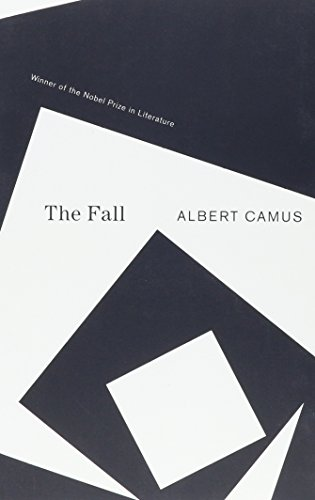Is this book related to Science Fiction & Fantasy? No, 'The Fall' is not associated with the Science Fiction & Fantasy genres; it is firmly rooted in existential and philosophical literature. 